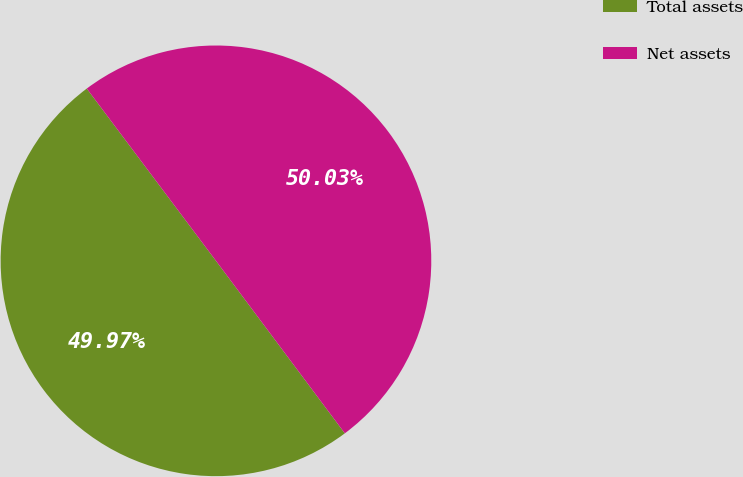Convert chart to OTSL. <chart><loc_0><loc_0><loc_500><loc_500><pie_chart><fcel>Total assets<fcel>Net assets<nl><fcel>49.97%<fcel>50.03%<nl></chart> 